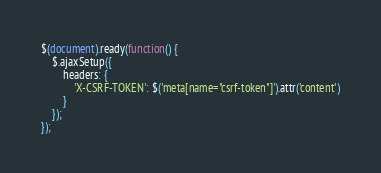<code> <loc_0><loc_0><loc_500><loc_500><_JavaScript_>$(document).ready(function() {
    $.ajaxSetup({
        headers: {
            'X-CSRF-TOKEN': $('meta[name="csrf-token"]').attr('content')
        }
    });
});</code> 